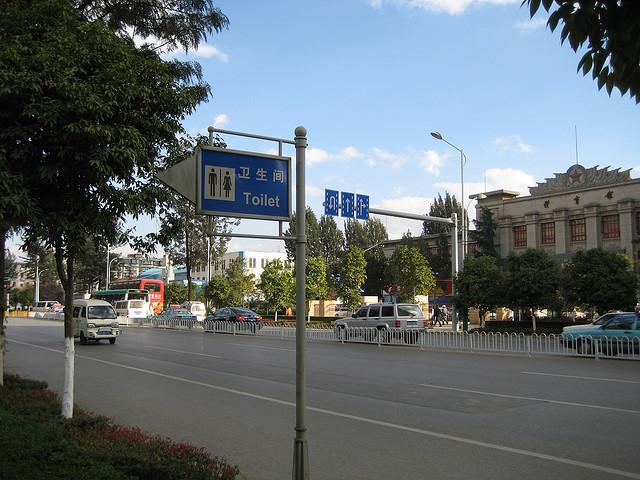What type of business is shown to the right?
Concise answer only. Courthouse. What are the white lines?
Write a very short answer. Lanes. What color are the light post?
Write a very short answer. Gray. Why is the base of the tree painted white?
Answer briefly. Safety. What does the sign say?
Be succinct. Toilet. Where is the nearest bathroom?
Concise answer only. Left. Is there a u-turn sign?
Quick response, please. Yes. 